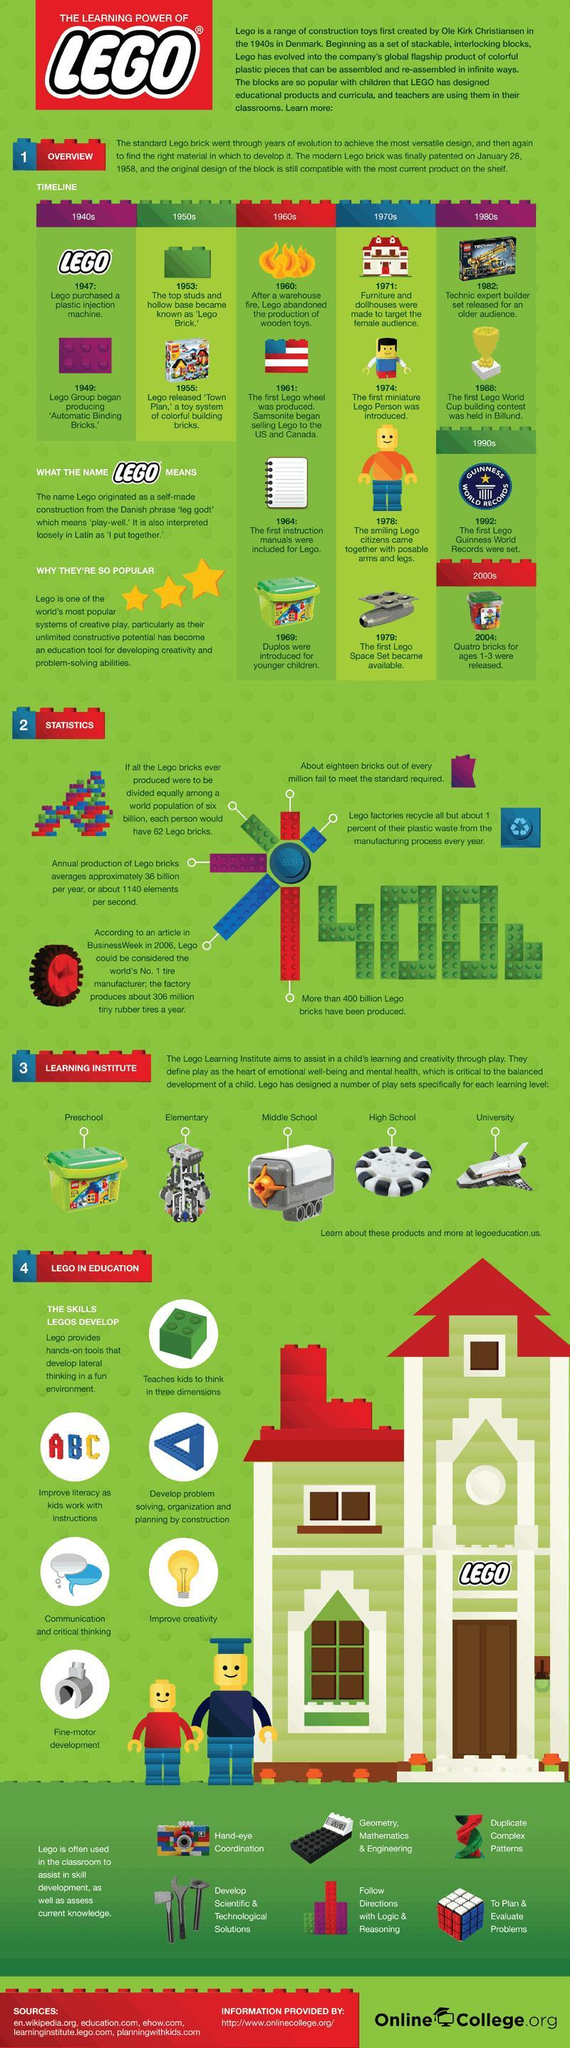In which country was Lego invented?
Answer the question with a short phrase. Denmark Which country hosted the first ever Lego world cup? Denmark In which year was the first Lego Guinness World Record set? 1992 Which city hosted the first ever Lego world cup? Billund In which year was the first Lego world cup took place? 1988 From which year did Lego started including manuals? 1964 In which year was the first Lego Space Set released? 1979 In which year was Quatro bricks for ages 1-3 released? 2004 In which year was the Lego invented? 1940 In which year was Duplos got introduced for younger children? 1969 